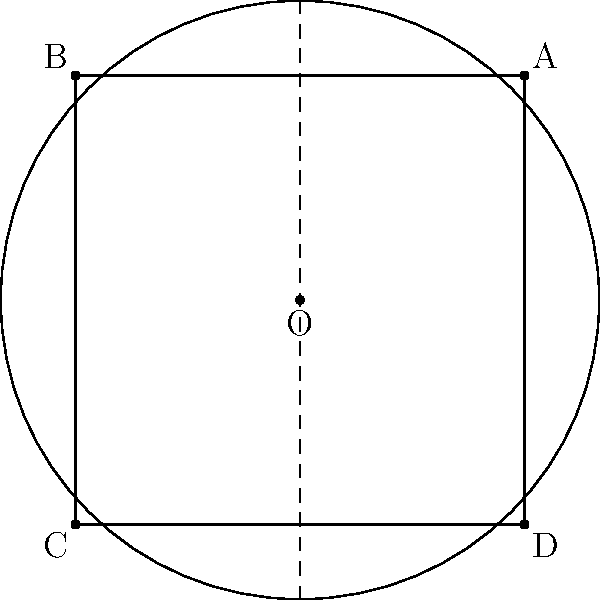In a hyperbolic concert venue modeled by the Poincaré disk model, sound waves travel along geodesics. If a speaker is placed at point A and the audience is seated along the line segment BC, what is the optimal placement of a sound-reflecting surface to ensure maximum coverage? Assume the reflecting surface is a geodesic arc. To solve this problem, we need to follow these steps:

1) In hyperbolic geometry, the concept of "perpendicular bisector" still exists, but it's different from Euclidean geometry.

2) The optimal placement for the reflecting surface would be along the perpendicular bisector of the angle ∠BOC, where O is the center of the Poincaré disk.

3) In the Poincaré disk model, geodesics are either diameters of the disk or arcs of circles that intersect the boundary circle at right angles.

4) The perpendicular bisector of ∠BOC will be the diameter EF, as shown in the diagram.

5) The reflecting surface should be placed along this diameter, specifically the segment OF.

6) This placement ensures that sound waves from A reflected off this surface will reach all points along BC.

7) In hyperbolic geometry, this reflecting surface acts like a parabolic mirror in Euclidean geometry, focusing parallel incoming waves to a single point (in this case, spreading waves from a point to a line).

8) This solution maximizes coverage because:
   a) It's equidistant from B and C in hyperbolic metric.
   b) It forms equal angles with OB and OC.
   c) Any other placement would favor one side over the other, reducing overall coverage.

9) In the context of sound engineering for concerts, this hyperbolic model can help in designing curved reflectors or acoustic panels to ensure even sound distribution in non-traditional venue shapes.
Answer: Along diameter EF, specifically segment OF 